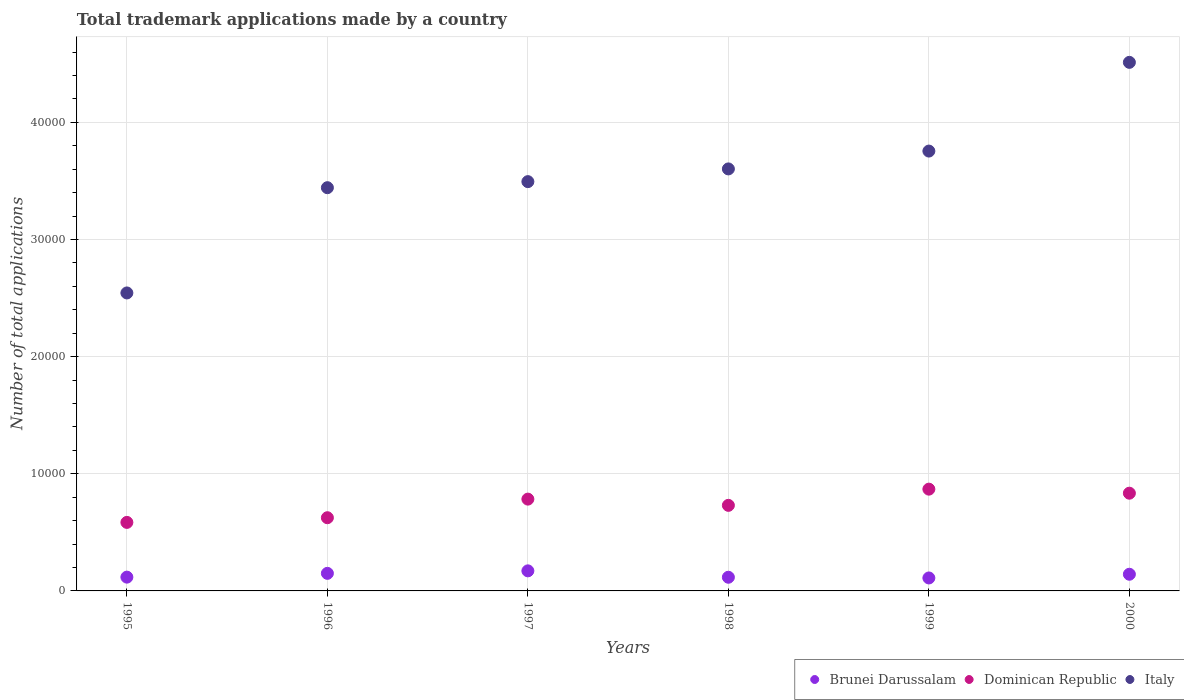Is the number of dotlines equal to the number of legend labels?
Keep it short and to the point. Yes. What is the number of applications made by in Brunei Darussalam in 1995?
Your response must be concise. 1177. Across all years, what is the maximum number of applications made by in Brunei Darussalam?
Keep it short and to the point. 1713. Across all years, what is the minimum number of applications made by in Brunei Darussalam?
Provide a short and direct response. 1106. In which year was the number of applications made by in Dominican Republic minimum?
Your answer should be compact. 1995. What is the total number of applications made by in Brunei Darussalam in the graph?
Your answer should be very brief. 8086. What is the difference between the number of applications made by in Italy in 1996 and that in 2000?
Offer a very short reply. -1.07e+04. What is the difference between the number of applications made by in Brunei Darussalam in 1995 and the number of applications made by in Dominican Republic in 2000?
Provide a short and direct response. -7166. What is the average number of applications made by in Brunei Darussalam per year?
Offer a very short reply. 1347.67. In the year 2000, what is the difference between the number of applications made by in Dominican Republic and number of applications made by in Italy?
Your answer should be very brief. -3.68e+04. What is the ratio of the number of applications made by in Dominican Republic in 1995 to that in 1999?
Your response must be concise. 0.67. Is the number of applications made by in Dominican Republic in 1998 less than that in 1999?
Keep it short and to the point. Yes. Is the difference between the number of applications made by in Dominican Republic in 1997 and 1999 greater than the difference between the number of applications made by in Italy in 1997 and 1999?
Provide a short and direct response. Yes. What is the difference between the highest and the second highest number of applications made by in Brunei Darussalam?
Your response must be concise. 213. What is the difference between the highest and the lowest number of applications made by in Italy?
Offer a terse response. 1.97e+04. Is the number of applications made by in Dominican Republic strictly less than the number of applications made by in Brunei Darussalam over the years?
Your response must be concise. No. How many dotlines are there?
Keep it short and to the point. 3. What is the difference between two consecutive major ticks on the Y-axis?
Give a very brief answer. 10000. Are the values on the major ticks of Y-axis written in scientific E-notation?
Your response must be concise. No. What is the title of the graph?
Keep it short and to the point. Total trademark applications made by a country. Does "West Bank and Gaza" appear as one of the legend labels in the graph?
Keep it short and to the point. No. What is the label or title of the Y-axis?
Keep it short and to the point. Number of total applications. What is the Number of total applications of Brunei Darussalam in 1995?
Provide a succinct answer. 1177. What is the Number of total applications in Dominican Republic in 1995?
Ensure brevity in your answer.  5850. What is the Number of total applications in Italy in 1995?
Make the answer very short. 2.54e+04. What is the Number of total applications in Brunei Darussalam in 1996?
Ensure brevity in your answer.  1500. What is the Number of total applications of Dominican Republic in 1996?
Your response must be concise. 6249. What is the Number of total applications in Italy in 1996?
Provide a succinct answer. 3.44e+04. What is the Number of total applications in Brunei Darussalam in 1997?
Your response must be concise. 1713. What is the Number of total applications of Dominican Republic in 1997?
Your answer should be very brief. 7837. What is the Number of total applications in Italy in 1997?
Give a very brief answer. 3.49e+04. What is the Number of total applications in Brunei Darussalam in 1998?
Ensure brevity in your answer.  1167. What is the Number of total applications in Dominican Republic in 1998?
Make the answer very short. 7305. What is the Number of total applications of Italy in 1998?
Give a very brief answer. 3.60e+04. What is the Number of total applications of Brunei Darussalam in 1999?
Offer a terse response. 1106. What is the Number of total applications in Dominican Republic in 1999?
Provide a succinct answer. 8688. What is the Number of total applications in Italy in 1999?
Make the answer very short. 3.75e+04. What is the Number of total applications of Brunei Darussalam in 2000?
Offer a terse response. 1423. What is the Number of total applications of Dominican Republic in 2000?
Keep it short and to the point. 8343. What is the Number of total applications of Italy in 2000?
Provide a short and direct response. 4.51e+04. Across all years, what is the maximum Number of total applications of Brunei Darussalam?
Give a very brief answer. 1713. Across all years, what is the maximum Number of total applications of Dominican Republic?
Provide a short and direct response. 8688. Across all years, what is the maximum Number of total applications in Italy?
Offer a terse response. 4.51e+04. Across all years, what is the minimum Number of total applications of Brunei Darussalam?
Ensure brevity in your answer.  1106. Across all years, what is the minimum Number of total applications in Dominican Republic?
Keep it short and to the point. 5850. Across all years, what is the minimum Number of total applications in Italy?
Ensure brevity in your answer.  2.54e+04. What is the total Number of total applications in Brunei Darussalam in the graph?
Give a very brief answer. 8086. What is the total Number of total applications in Dominican Republic in the graph?
Offer a very short reply. 4.43e+04. What is the total Number of total applications of Italy in the graph?
Ensure brevity in your answer.  2.13e+05. What is the difference between the Number of total applications in Brunei Darussalam in 1995 and that in 1996?
Your response must be concise. -323. What is the difference between the Number of total applications of Dominican Republic in 1995 and that in 1996?
Ensure brevity in your answer.  -399. What is the difference between the Number of total applications of Italy in 1995 and that in 1996?
Provide a short and direct response. -8985. What is the difference between the Number of total applications in Brunei Darussalam in 1995 and that in 1997?
Keep it short and to the point. -536. What is the difference between the Number of total applications of Dominican Republic in 1995 and that in 1997?
Offer a terse response. -1987. What is the difference between the Number of total applications of Italy in 1995 and that in 1997?
Your answer should be very brief. -9502. What is the difference between the Number of total applications in Brunei Darussalam in 1995 and that in 1998?
Make the answer very short. 10. What is the difference between the Number of total applications of Dominican Republic in 1995 and that in 1998?
Give a very brief answer. -1455. What is the difference between the Number of total applications of Italy in 1995 and that in 1998?
Give a very brief answer. -1.06e+04. What is the difference between the Number of total applications of Brunei Darussalam in 1995 and that in 1999?
Your answer should be very brief. 71. What is the difference between the Number of total applications of Dominican Republic in 1995 and that in 1999?
Offer a terse response. -2838. What is the difference between the Number of total applications in Italy in 1995 and that in 1999?
Offer a very short reply. -1.21e+04. What is the difference between the Number of total applications of Brunei Darussalam in 1995 and that in 2000?
Offer a terse response. -246. What is the difference between the Number of total applications in Dominican Republic in 1995 and that in 2000?
Keep it short and to the point. -2493. What is the difference between the Number of total applications in Italy in 1995 and that in 2000?
Provide a succinct answer. -1.97e+04. What is the difference between the Number of total applications in Brunei Darussalam in 1996 and that in 1997?
Keep it short and to the point. -213. What is the difference between the Number of total applications of Dominican Republic in 1996 and that in 1997?
Ensure brevity in your answer.  -1588. What is the difference between the Number of total applications in Italy in 1996 and that in 1997?
Make the answer very short. -517. What is the difference between the Number of total applications in Brunei Darussalam in 1996 and that in 1998?
Ensure brevity in your answer.  333. What is the difference between the Number of total applications in Dominican Republic in 1996 and that in 1998?
Your response must be concise. -1056. What is the difference between the Number of total applications of Italy in 1996 and that in 1998?
Your answer should be very brief. -1603. What is the difference between the Number of total applications in Brunei Darussalam in 1996 and that in 1999?
Ensure brevity in your answer.  394. What is the difference between the Number of total applications in Dominican Republic in 1996 and that in 1999?
Your answer should be compact. -2439. What is the difference between the Number of total applications of Italy in 1996 and that in 1999?
Offer a terse response. -3126. What is the difference between the Number of total applications in Brunei Darussalam in 1996 and that in 2000?
Give a very brief answer. 77. What is the difference between the Number of total applications of Dominican Republic in 1996 and that in 2000?
Give a very brief answer. -2094. What is the difference between the Number of total applications of Italy in 1996 and that in 2000?
Ensure brevity in your answer.  -1.07e+04. What is the difference between the Number of total applications in Brunei Darussalam in 1997 and that in 1998?
Offer a very short reply. 546. What is the difference between the Number of total applications of Dominican Republic in 1997 and that in 1998?
Offer a terse response. 532. What is the difference between the Number of total applications in Italy in 1997 and that in 1998?
Make the answer very short. -1086. What is the difference between the Number of total applications of Brunei Darussalam in 1997 and that in 1999?
Give a very brief answer. 607. What is the difference between the Number of total applications in Dominican Republic in 1997 and that in 1999?
Keep it short and to the point. -851. What is the difference between the Number of total applications in Italy in 1997 and that in 1999?
Offer a very short reply. -2609. What is the difference between the Number of total applications of Brunei Darussalam in 1997 and that in 2000?
Give a very brief answer. 290. What is the difference between the Number of total applications in Dominican Republic in 1997 and that in 2000?
Ensure brevity in your answer.  -506. What is the difference between the Number of total applications of Italy in 1997 and that in 2000?
Offer a very short reply. -1.02e+04. What is the difference between the Number of total applications in Dominican Republic in 1998 and that in 1999?
Keep it short and to the point. -1383. What is the difference between the Number of total applications of Italy in 1998 and that in 1999?
Your response must be concise. -1523. What is the difference between the Number of total applications of Brunei Darussalam in 1998 and that in 2000?
Provide a succinct answer. -256. What is the difference between the Number of total applications in Dominican Republic in 1998 and that in 2000?
Offer a very short reply. -1038. What is the difference between the Number of total applications of Italy in 1998 and that in 2000?
Your answer should be very brief. -9097. What is the difference between the Number of total applications in Brunei Darussalam in 1999 and that in 2000?
Make the answer very short. -317. What is the difference between the Number of total applications of Dominican Republic in 1999 and that in 2000?
Your answer should be very brief. 345. What is the difference between the Number of total applications of Italy in 1999 and that in 2000?
Offer a very short reply. -7574. What is the difference between the Number of total applications of Brunei Darussalam in 1995 and the Number of total applications of Dominican Republic in 1996?
Offer a very short reply. -5072. What is the difference between the Number of total applications of Brunei Darussalam in 1995 and the Number of total applications of Italy in 1996?
Offer a very short reply. -3.32e+04. What is the difference between the Number of total applications of Dominican Republic in 1995 and the Number of total applications of Italy in 1996?
Keep it short and to the point. -2.86e+04. What is the difference between the Number of total applications of Brunei Darussalam in 1995 and the Number of total applications of Dominican Republic in 1997?
Offer a terse response. -6660. What is the difference between the Number of total applications in Brunei Darussalam in 1995 and the Number of total applications in Italy in 1997?
Your answer should be compact. -3.38e+04. What is the difference between the Number of total applications in Dominican Republic in 1995 and the Number of total applications in Italy in 1997?
Your response must be concise. -2.91e+04. What is the difference between the Number of total applications in Brunei Darussalam in 1995 and the Number of total applications in Dominican Republic in 1998?
Offer a very short reply. -6128. What is the difference between the Number of total applications in Brunei Darussalam in 1995 and the Number of total applications in Italy in 1998?
Give a very brief answer. -3.48e+04. What is the difference between the Number of total applications of Dominican Republic in 1995 and the Number of total applications of Italy in 1998?
Your answer should be very brief. -3.02e+04. What is the difference between the Number of total applications in Brunei Darussalam in 1995 and the Number of total applications in Dominican Republic in 1999?
Ensure brevity in your answer.  -7511. What is the difference between the Number of total applications in Brunei Darussalam in 1995 and the Number of total applications in Italy in 1999?
Your response must be concise. -3.64e+04. What is the difference between the Number of total applications of Dominican Republic in 1995 and the Number of total applications of Italy in 1999?
Give a very brief answer. -3.17e+04. What is the difference between the Number of total applications of Brunei Darussalam in 1995 and the Number of total applications of Dominican Republic in 2000?
Ensure brevity in your answer.  -7166. What is the difference between the Number of total applications of Brunei Darussalam in 1995 and the Number of total applications of Italy in 2000?
Offer a terse response. -4.39e+04. What is the difference between the Number of total applications of Dominican Republic in 1995 and the Number of total applications of Italy in 2000?
Keep it short and to the point. -3.93e+04. What is the difference between the Number of total applications in Brunei Darussalam in 1996 and the Number of total applications in Dominican Republic in 1997?
Keep it short and to the point. -6337. What is the difference between the Number of total applications of Brunei Darussalam in 1996 and the Number of total applications of Italy in 1997?
Keep it short and to the point. -3.34e+04. What is the difference between the Number of total applications of Dominican Republic in 1996 and the Number of total applications of Italy in 1997?
Your answer should be very brief. -2.87e+04. What is the difference between the Number of total applications of Brunei Darussalam in 1996 and the Number of total applications of Dominican Republic in 1998?
Your answer should be very brief. -5805. What is the difference between the Number of total applications of Brunei Darussalam in 1996 and the Number of total applications of Italy in 1998?
Offer a terse response. -3.45e+04. What is the difference between the Number of total applications of Dominican Republic in 1996 and the Number of total applications of Italy in 1998?
Keep it short and to the point. -2.98e+04. What is the difference between the Number of total applications in Brunei Darussalam in 1996 and the Number of total applications in Dominican Republic in 1999?
Ensure brevity in your answer.  -7188. What is the difference between the Number of total applications in Brunei Darussalam in 1996 and the Number of total applications in Italy in 1999?
Keep it short and to the point. -3.60e+04. What is the difference between the Number of total applications in Dominican Republic in 1996 and the Number of total applications in Italy in 1999?
Keep it short and to the point. -3.13e+04. What is the difference between the Number of total applications in Brunei Darussalam in 1996 and the Number of total applications in Dominican Republic in 2000?
Make the answer very short. -6843. What is the difference between the Number of total applications in Brunei Darussalam in 1996 and the Number of total applications in Italy in 2000?
Keep it short and to the point. -4.36e+04. What is the difference between the Number of total applications in Dominican Republic in 1996 and the Number of total applications in Italy in 2000?
Your answer should be compact. -3.89e+04. What is the difference between the Number of total applications of Brunei Darussalam in 1997 and the Number of total applications of Dominican Republic in 1998?
Provide a short and direct response. -5592. What is the difference between the Number of total applications of Brunei Darussalam in 1997 and the Number of total applications of Italy in 1998?
Offer a very short reply. -3.43e+04. What is the difference between the Number of total applications of Dominican Republic in 1997 and the Number of total applications of Italy in 1998?
Ensure brevity in your answer.  -2.82e+04. What is the difference between the Number of total applications of Brunei Darussalam in 1997 and the Number of total applications of Dominican Republic in 1999?
Keep it short and to the point. -6975. What is the difference between the Number of total applications of Brunei Darussalam in 1997 and the Number of total applications of Italy in 1999?
Your response must be concise. -3.58e+04. What is the difference between the Number of total applications of Dominican Republic in 1997 and the Number of total applications of Italy in 1999?
Offer a very short reply. -2.97e+04. What is the difference between the Number of total applications of Brunei Darussalam in 1997 and the Number of total applications of Dominican Republic in 2000?
Offer a very short reply. -6630. What is the difference between the Number of total applications of Brunei Darussalam in 1997 and the Number of total applications of Italy in 2000?
Offer a very short reply. -4.34e+04. What is the difference between the Number of total applications in Dominican Republic in 1997 and the Number of total applications in Italy in 2000?
Provide a succinct answer. -3.73e+04. What is the difference between the Number of total applications of Brunei Darussalam in 1998 and the Number of total applications of Dominican Republic in 1999?
Offer a very short reply. -7521. What is the difference between the Number of total applications in Brunei Darussalam in 1998 and the Number of total applications in Italy in 1999?
Offer a very short reply. -3.64e+04. What is the difference between the Number of total applications of Dominican Republic in 1998 and the Number of total applications of Italy in 1999?
Your answer should be very brief. -3.02e+04. What is the difference between the Number of total applications of Brunei Darussalam in 1998 and the Number of total applications of Dominican Republic in 2000?
Give a very brief answer. -7176. What is the difference between the Number of total applications in Brunei Darussalam in 1998 and the Number of total applications in Italy in 2000?
Your response must be concise. -4.40e+04. What is the difference between the Number of total applications of Dominican Republic in 1998 and the Number of total applications of Italy in 2000?
Provide a short and direct response. -3.78e+04. What is the difference between the Number of total applications in Brunei Darussalam in 1999 and the Number of total applications in Dominican Republic in 2000?
Your response must be concise. -7237. What is the difference between the Number of total applications in Brunei Darussalam in 1999 and the Number of total applications in Italy in 2000?
Make the answer very short. -4.40e+04. What is the difference between the Number of total applications in Dominican Republic in 1999 and the Number of total applications in Italy in 2000?
Your response must be concise. -3.64e+04. What is the average Number of total applications in Brunei Darussalam per year?
Provide a succinct answer. 1347.67. What is the average Number of total applications in Dominican Republic per year?
Make the answer very short. 7378.67. What is the average Number of total applications of Italy per year?
Provide a short and direct response. 3.56e+04. In the year 1995, what is the difference between the Number of total applications of Brunei Darussalam and Number of total applications of Dominican Republic?
Make the answer very short. -4673. In the year 1995, what is the difference between the Number of total applications of Brunei Darussalam and Number of total applications of Italy?
Offer a terse response. -2.43e+04. In the year 1995, what is the difference between the Number of total applications in Dominican Republic and Number of total applications in Italy?
Keep it short and to the point. -1.96e+04. In the year 1996, what is the difference between the Number of total applications in Brunei Darussalam and Number of total applications in Dominican Republic?
Provide a short and direct response. -4749. In the year 1996, what is the difference between the Number of total applications of Brunei Darussalam and Number of total applications of Italy?
Your answer should be compact. -3.29e+04. In the year 1996, what is the difference between the Number of total applications in Dominican Republic and Number of total applications in Italy?
Make the answer very short. -2.82e+04. In the year 1997, what is the difference between the Number of total applications in Brunei Darussalam and Number of total applications in Dominican Republic?
Ensure brevity in your answer.  -6124. In the year 1997, what is the difference between the Number of total applications in Brunei Darussalam and Number of total applications in Italy?
Give a very brief answer. -3.32e+04. In the year 1997, what is the difference between the Number of total applications in Dominican Republic and Number of total applications in Italy?
Your answer should be compact. -2.71e+04. In the year 1998, what is the difference between the Number of total applications in Brunei Darussalam and Number of total applications in Dominican Republic?
Give a very brief answer. -6138. In the year 1998, what is the difference between the Number of total applications of Brunei Darussalam and Number of total applications of Italy?
Your answer should be very brief. -3.49e+04. In the year 1998, what is the difference between the Number of total applications in Dominican Republic and Number of total applications in Italy?
Your response must be concise. -2.87e+04. In the year 1999, what is the difference between the Number of total applications in Brunei Darussalam and Number of total applications in Dominican Republic?
Make the answer very short. -7582. In the year 1999, what is the difference between the Number of total applications in Brunei Darussalam and Number of total applications in Italy?
Your response must be concise. -3.64e+04. In the year 1999, what is the difference between the Number of total applications in Dominican Republic and Number of total applications in Italy?
Provide a succinct answer. -2.89e+04. In the year 2000, what is the difference between the Number of total applications of Brunei Darussalam and Number of total applications of Dominican Republic?
Offer a terse response. -6920. In the year 2000, what is the difference between the Number of total applications in Brunei Darussalam and Number of total applications in Italy?
Provide a succinct answer. -4.37e+04. In the year 2000, what is the difference between the Number of total applications of Dominican Republic and Number of total applications of Italy?
Your answer should be compact. -3.68e+04. What is the ratio of the Number of total applications in Brunei Darussalam in 1995 to that in 1996?
Provide a succinct answer. 0.78. What is the ratio of the Number of total applications of Dominican Republic in 1995 to that in 1996?
Your answer should be very brief. 0.94. What is the ratio of the Number of total applications in Italy in 1995 to that in 1996?
Give a very brief answer. 0.74. What is the ratio of the Number of total applications of Brunei Darussalam in 1995 to that in 1997?
Your answer should be compact. 0.69. What is the ratio of the Number of total applications in Dominican Republic in 1995 to that in 1997?
Ensure brevity in your answer.  0.75. What is the ratio of the Number of total applications in Italy in 1995 to that in 1997?
Ensure brevity in your answer.  0.73. What is the ratio of the Number of total applications of Brunei Darussalam in 1995 to that in 1998?
Your answer should be very brief. 1.01. What is the ratio of the Number of total applications of Dominican Republic in 1995 to that in 1998?
Provide a short and direct response. 0.8. What is the ratio of the Number of total applications of Italy in 1995 to that in 1998?
Your response must be concise. 0.71. What is the ratio of the Number of total applications in Brunei Darussalam in 1995 to that in 1999?
Keep it short and to the point. 1.06. What is the ratio of the Number of total applications of Dominican Republic in 1995 to that in 1999?
Ensure brevity in your answer.  0.67. What is the ratio of the Number of total applications of Italy in 1995 to that in 1999?
Ensure brevity in your answer.  0.68. What is the ratio of the Number of total applications in Brunei Darussalam in 1995 to that in 2000?
Make the answer very short. 0.83. What is the ratio of the Number of total applications in Dominican Republic in 1995 to that in 2000?
Offer a very short reply. 0.7. What is the ratio of the Number of total applications in Italy in 1995 to that in 2000?
Your answer should be compact. 0.56. What is the ratio of the Number of total applications in Brunei Darussalam in 1996 to that in 1997?
Your answer should be very brief. 0.88. What is the ratio of the Number of total applications of Dominican Republic in 1996 to that in 1997?
Offer a terse response. 0.8. What is the ratio of the Number of total applications in Italy in 1996 to that in 1997?
Offer a terse response. 0.99. What is the ratio of the Number of total applications of Brunei Darussalam in 1996 to that in 1998?
Make the answer very short. 1.29. What is the ratio of the Number of total applications in Dominican Republic in 1996 to that in 1998?
Provide a succinct answer. 0.86. What is the ratio of the Number of total applications of Italy in 1996 to that in 1998?
Make the answer very short. 0.96. What is the ratio of the Number of total applications in Brunei Darussalam in 1996 to that in 1999?
Ensure brevity in your answer.  1.36. What is the ratio of the Number of total applications in Dominican Republic in 1996 to that in 1999?
Keep it short and to the point. 0.72. What is the ratio of the Number of total applications of Brunei Darussalam in 1996 to that in 2000?
Your answer should be compact. 1.05. What is the ratio of the Number of total applications of Dominican Republic in 1996 to that in 2000?
Make the answer very short. 0.75. What is the ratio of the Number of total applications of Italy in 1996 to that in 2000?
Your answer should be compact. 0.76. What is the ratio of the Number of total applications in Brunei Darussalam in 1997 to that in 1998?
Provide a short and direct response. 1.47. What is the ratio of the Number of total applications of Dominican Republic in 1997 to that in 1998?
Provide a succinct answer. 1.07. What is the ratio of the Number of total applications of Italy in 1997 to that in 1998?
Your answer should be very brief. 0.97. What is the ratio of the Number of total applications in Brunei Darussalam in 1997 to that in 1999?
Ensure brevity in your answer.  1.55. What is the ratio of the Number of total applications of Dominican Republic in 1997 to that in 1999?
Ensure brevity in your answer.  0.9. What is the ratio of the Number of total applications in Italy in 1997 to that in 1999?
Give a very brief answer. 0.93. What is the ratio of the Number of total applications of Brunei Darussalam in 1997 to that in 2000?
Give a very brief answer. 1.2. What is the ratio of the Number of total applications in Dominican Republic in 1997 to that in 2000?
Provide a succinct answer. 0.94. What is the ratio of the Number of total applications of Italy in 1997 to that in 2000?
Your answer should be compact. 0.77. What is the ratio of the Number of total applications of Brunei Darussalam in 1998 to that in 1999?
Your answer should be compact. 1.06. What is the ratio of the Number of total applications in Dominican Republic in 1998 to that in 1999?
Your answer should be very brief. 0.84. What is the ratio of the Number of total applications in Italy in 1998 to that in 1999?
Provide a succinct answer. 0.96. What is the ratio of the Number of total applications in Brunei Darussalam in 1998 to that in 2000?
Keep it short and to the point. 0.82. What is the ratio of the Number of total applications in Dominican Republic in 1998 to that in 2000?
Give a very brief answer. 0.88. What is the ratio of the Number of total applications in Italy in 1998 to that in 2000?
Provide a short and direct response. 0.8. What is the ratio of the Number of total applications of Brunei Darussalam in 1999 to that in 2000?
Provide a succinct answer. 0.78. What is the ratio of the Number of total applications in Dominican Republic in 1999 to that in 2000?
Make the answer very short. 1.04. What is the ratio of the Number of total applications in Italy in 1999 to that in 2000?
Offer a terse response. 0.83. What is the difference between the highest and the second highest Number of total applications of Brunei Darussalam?
Give a very brief answer. 213. What is the difference between the highest and the second highest Number of total applications of Dominican Republic?
Ensure brevity in your answer.  345. What is the difference between the highest and the second highest Number of total applications in Italy?
Your response must be concise. 7574. What is the difference between the highest and the lowest Number of total applications of Brunei Darussalam?
Your answer should be very brief. 607. What is the difference between the highest and the lowest Number of total applications in Dominican Republic?
Give a very brief answer. 2838. What is the difference between the highest and the lowest Number of total applications in Italy?
Provide a short and direct response. 1.97e+04. 